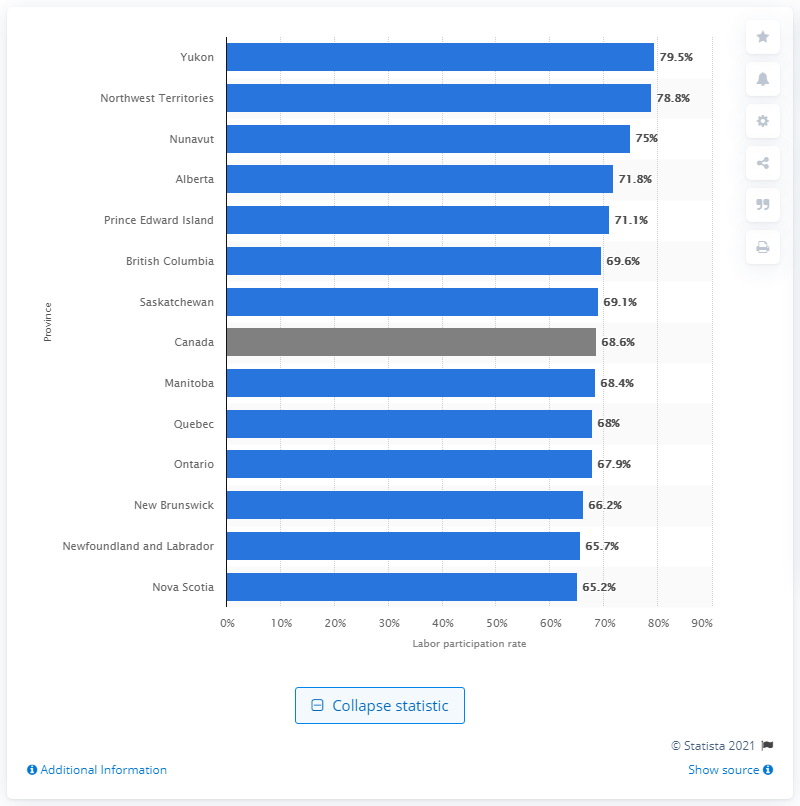Indicate a few pertinent items in this graphic. Canada has the highest labor participation rate among all countries. In 2018, the labor participation rate in Ontario was 68.4%. 